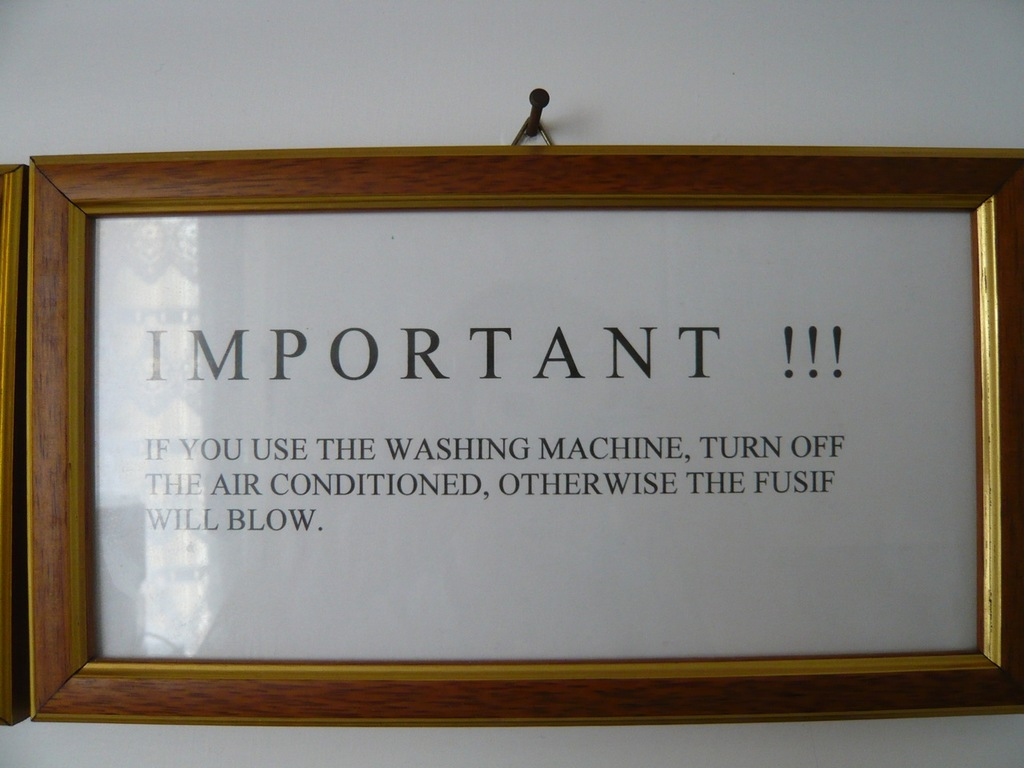How can residents prevent such issues in buildings with these electrical limitations? Residents can prevent electrical overloads by staggering the use of high-energy appliances. Installing more robust circuit breakers and upgrading wiring can also help manage higher loads. It's advisable to consult a professional electrician to assess the electrical system and make necessary upgrades to safely distribute power for all appliances. 